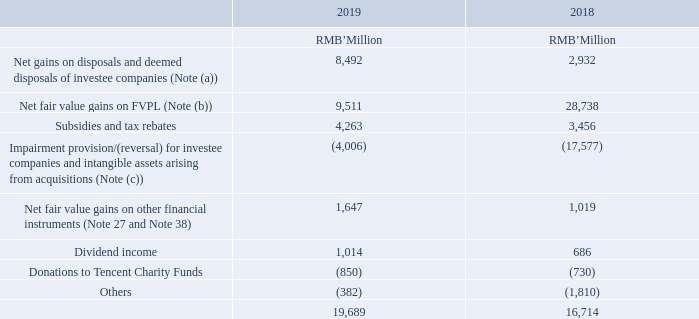7 OTHER GAINS, NET
Note: (a) The disposal and deemed disposal gains of approximately RMB8,492 million recognised during the year ended 31 December 2019 mainly comprised the following:
– net gains of approximately RMB4,859 million (2018: RMB1,661 million) on dilution of the Group’s equity interests in certain associates due to new equity interests being issued by these associates (Note 21). These investee companies are principally engaged in Internet-related business; and
– aggregate net gains of approximately RMB3,633 million (2018: RMB1,271 million) on disposals, partial disposals or deemed disposals of various investments of the Group.
(b) Net fair value gains on FVPL of approximately RMB9,511 million (Note 24) recognised during the year ended 31 December 2019 mainly comprised the following:
– aggregate gains of approximately RMB1,886 million (2018: RMB22,215 million) arising from reclassification of several investments principally engaged in Internet-related business from FVPL to investments in associates due to the conversion of the Group’s redeemable instruments or preferred shares of these investee companies into their ordinary shares and the Group has board representation upon their respective initial public offerings (“IPO”); and
– net gains of approximately RMB7,625 million (2018: RMB6,523 million) from fair value changes of FVPL.
How much is the 2019 subsidies and tax rebates?
Answer scale should be: million. 4,263. How much is the 2018 subsidies and tax rebates?
Answer scale should be: million. 3,456. How much is the 2019 dividend income?
Answer scale should be: million. 1,014. What is the change in Net fair value gains on FVPL from 2018 to 2019?
Answer scale should be: million. 9,511-28,738
Answer: -19227. What is the change in subsidies and tax rebates from 2018 to 2019?
Answer scale should be: million. 4,263-3,456
Answer: 807. What is the change in dividend income from 2018 to 2019?
Answer scale should be: million. 1,014-686
Answer: 328. 